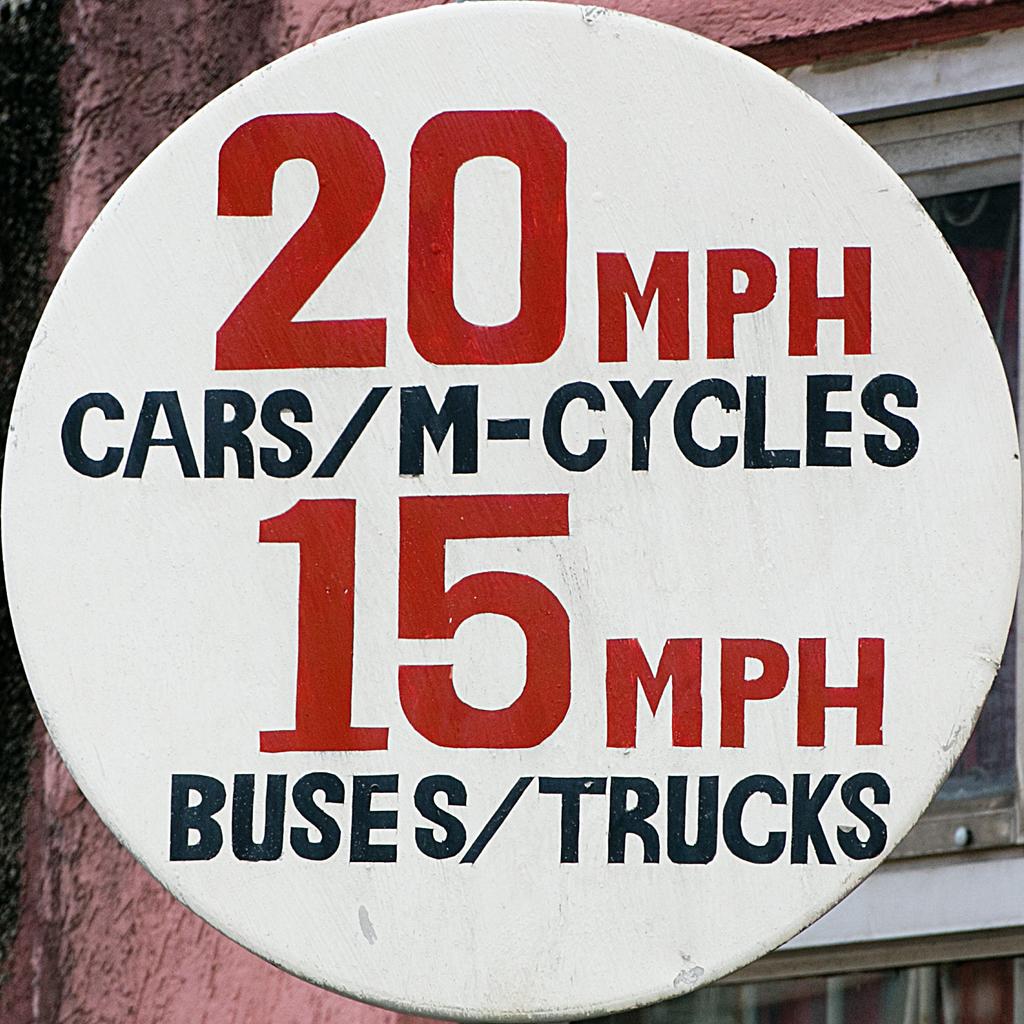What is the speed limit for cars?
Give a very brief answer. 20 mph. What is the speed limit for trucks?
Keep it short and to the point. 15 mph. 